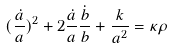Convert formula to latex. <formula><loc_0><loc_0><loc_500><loc_500>( \frac { \dot { a } } { a } ) ^ { 2 } + 2 \frac { \dot { a } } { a } \frac { \dot { b } } { b } + \frac { k } { a ^ { 2 } } = \kappa \rho</formula> 